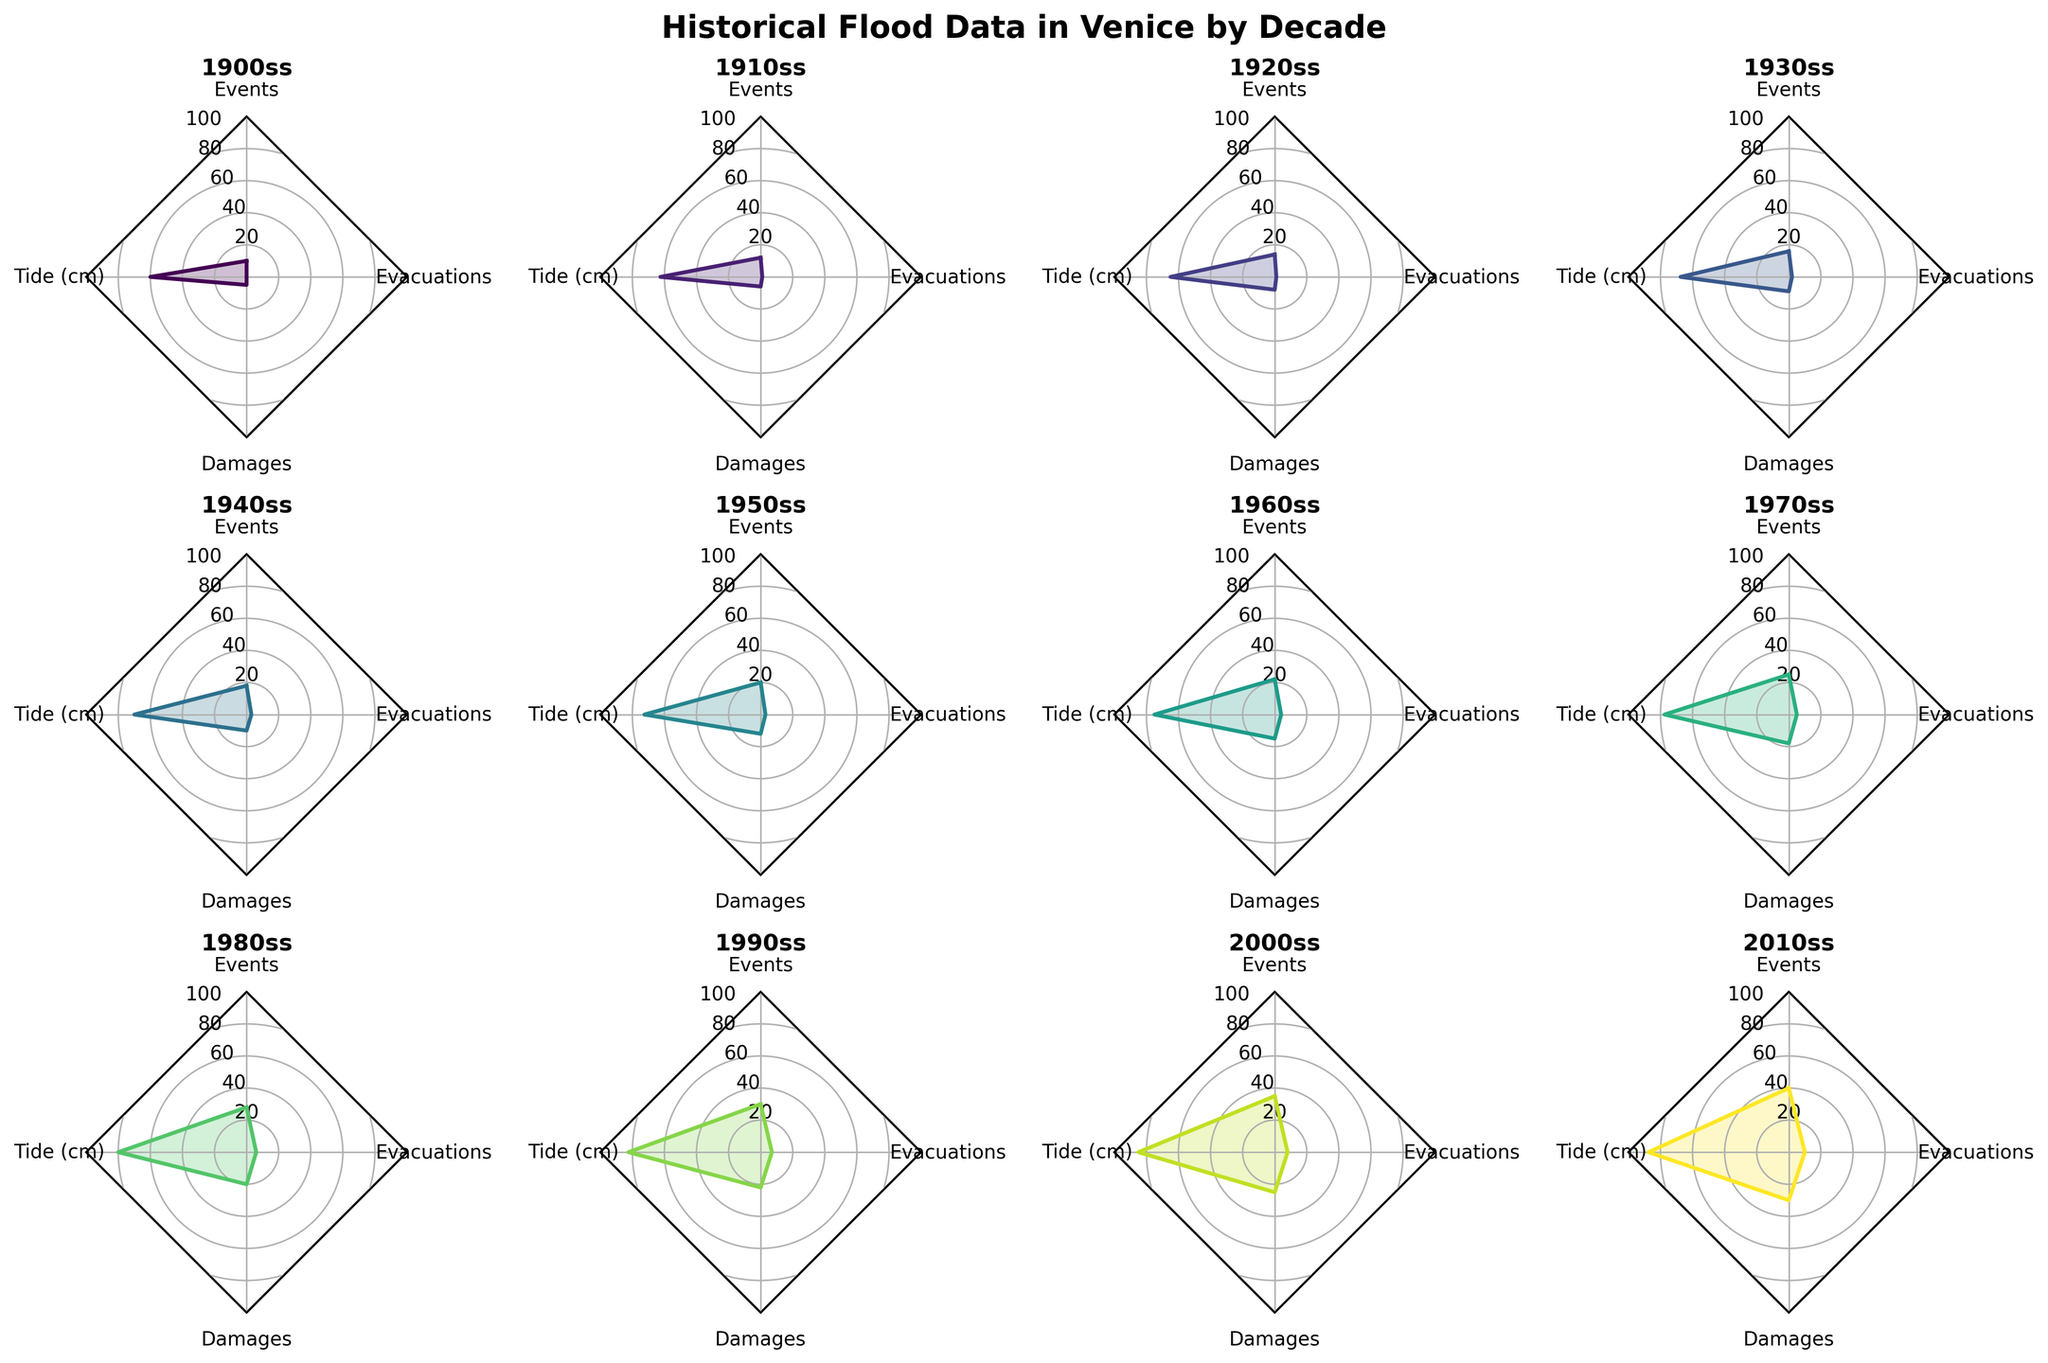What decade had the most flood events? The radar chart shows a consistent increase in flood events over the decades. The most recent decade displayed (2010s) has the highest values in the "Events" category.
Answer: 2010s What is the average peak tide in the 1980s? By looking at the "Tide (cm)" axis for the subplot of the 1980s, we see that the value is halfway between 4 and 5, indicating an average peak tide of 160 cm. Since the values are scaled down by half in the radar chart, the actual value is 160 cm.
Answer: 160 cm Which decade experienced the highest number of evacuations? The subplot for each decade shows the evacuations as one of the axes. The 2010s have the most extended value on the "Evacuations" axis, indicating the highest number of evacuations.
Answer: 2010s Compare the structural damages between the 1950s and 2010s. The 1950s subplot shows a value of around 12 on the "Damages" axis, while the 2010s show 30, indicating that the structural damages were significantly higher in the 2010s compared to the 1950s.
Answer: 2010s What is the sum of Acqua Alta Events and Structural Damages in the 1940s? In the subplot for the 1940s, we can see the values for "Events" as 18 and "Damages" as 10. Adding these two values gives us 18 + 10 = 28.
Answer: 28 Which decade had the least average peak tide? By examining the "Tide (cm)" axis across all subplots, the 1900s have the smallest value, indicating the lowest average peak tide.
Answer: 1900s How did the number of Acqua Alta Events change from the 2000s to the 2010s? Comparing the "Events" axis for the 2000s and 2010s subplots shows an increase from 35 in the 2000s to 40 in the 2010s.
Answer: Increased Which decade shows the most balanced distribution across all four categories? A decade is most balanced if its radar chart values are similar in length across all axes. The 1900s and 1910s subplots show the most balanced distribution as their values for "Events," "Tide," "Damages," and "Evacuations" are relatively close to each other.
Answer: 1900s and 1910s What is the difference in average peak tide between the 1930s and the 1950s? In the radar chart, the "Tide (cm)" axis for the 1930s shows 135 cm and for the 1950s shows 145 cm. The difference is 145 - 135 = 10 cm.
Answer: 10 cm 